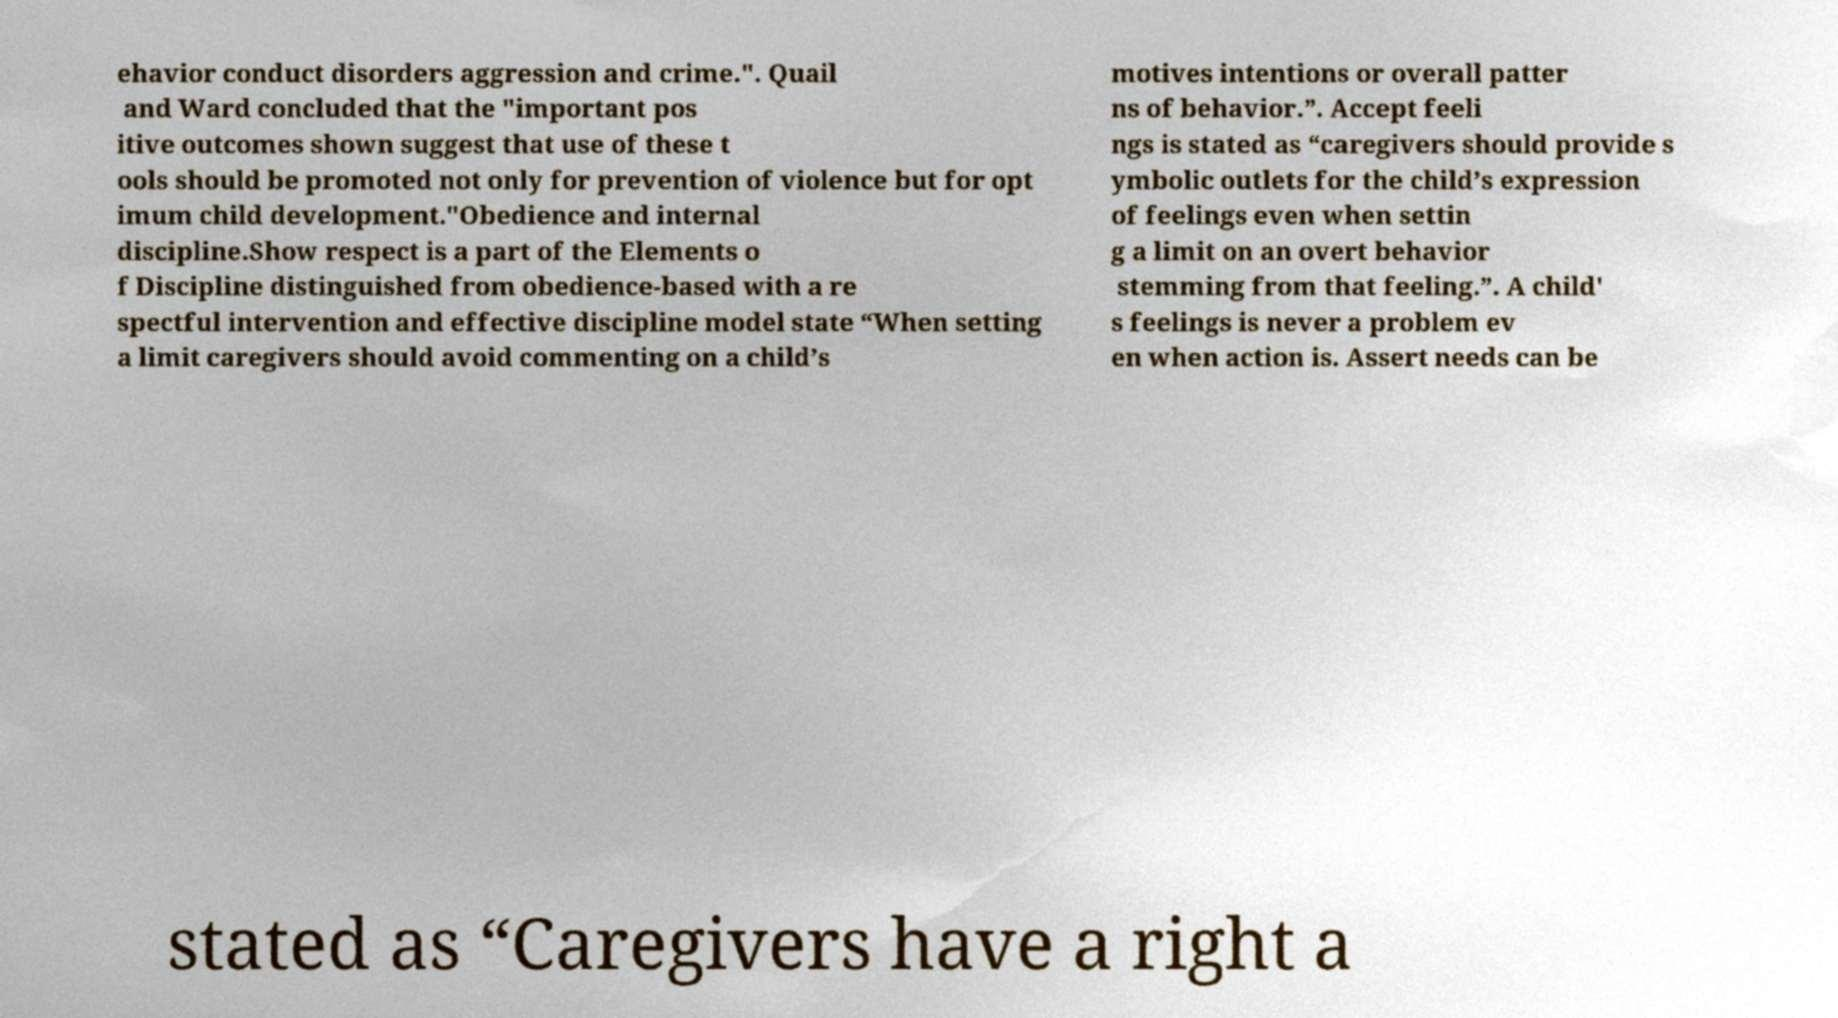What messages or text are displayed in this image? I need them in a readable, typed format. ehavior conduct disorders aggression and crime.". Quail and Ward concluded that the "important pos itive outcomes shown suggest that use of these t ools should be promoted not only for prevention of violence but for opt imum child development."Obedience and internal discipline.Show respect is a part of the Elements o f Discipline distinguished from obedience-based with a re spectful intervention and effective discipline model state “When setting a limit caregivers should avoid commenting on a child’s motives intentions or overall patter ns of behavior.”. Accept feeli ngs is stated as “caregivers should provide s ymbolic outlets for the child’s expression of feelings even when settin g a limit on an overt behavior stemming from that feeling.”. A child' s feelings is never a problem ev en when action is. Assert needs can be stated as “Caregivers have a right a 